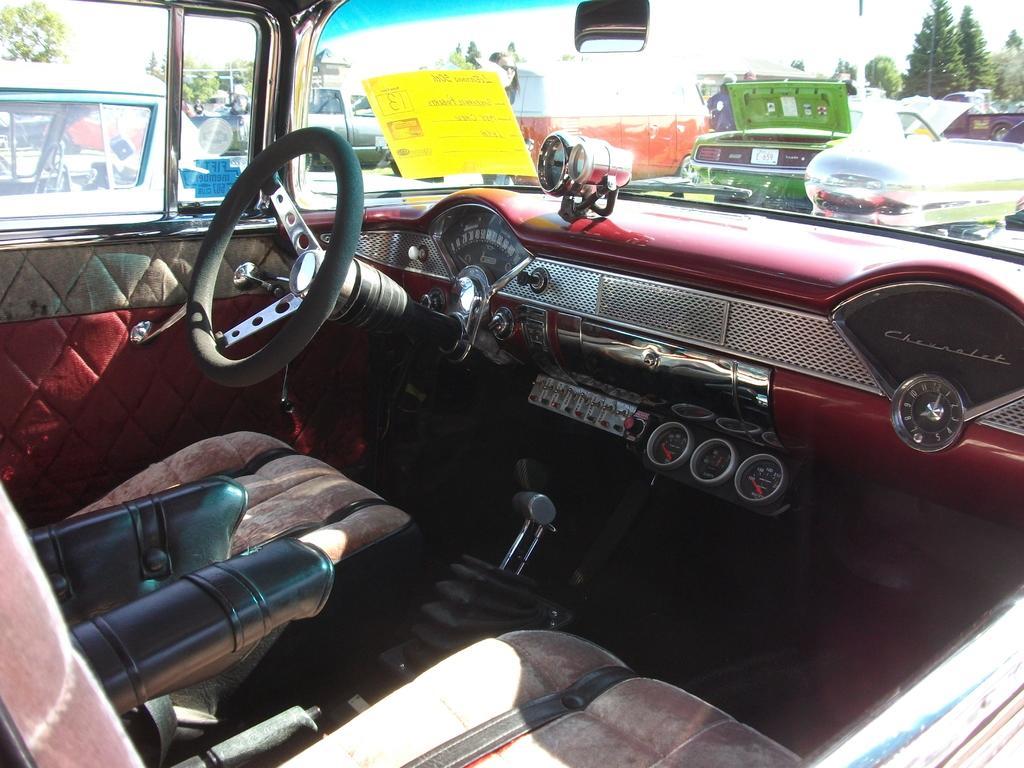Describe this image in one or two sentences. In this image, we can see some cars. There is a cockpit in the middle of the image. There are seats at the bottom of the image. There are trees in the top right of the image. 